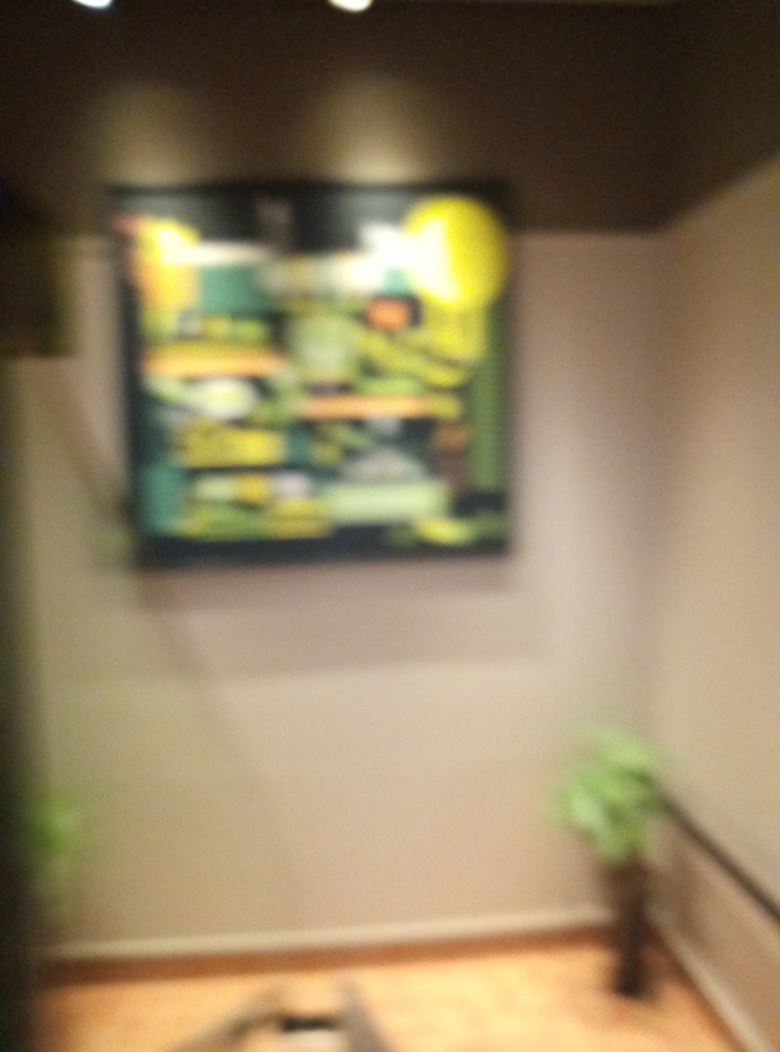Can you describe the ambiance of the room based on this image? The room appears to have a cozy and warm ambiance, with soft lighting that creates a calm and inviting space. The presence of the plant adds a touch of nature and life, which can enhance the sense of tranquility. The angle of the image and the furniture glimpsed at the edges suggest a domestic setting, perhaps a living room or a private study. What emotions might this image evoke? The overall composition with soft lighting, the presence of a potted plant, and the indistinct artwork can evoke feelings of relaxation and introspection. It might also stir a sense of curiosity or mystery due to the blurred content, urging viewers to fill in the gaps with their imagination. 